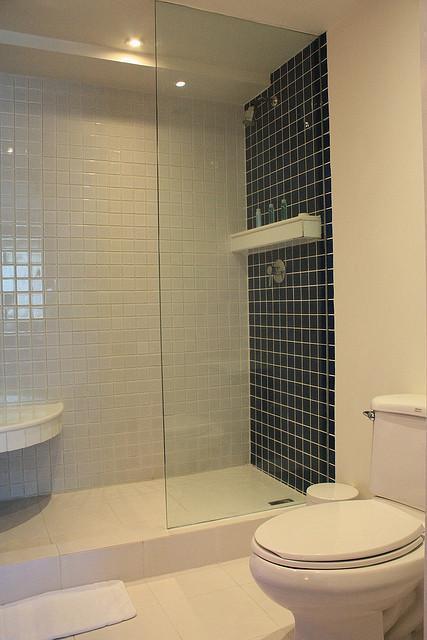How many of the kites are shaped like an iguana?
Give a very brief answer. 0. 